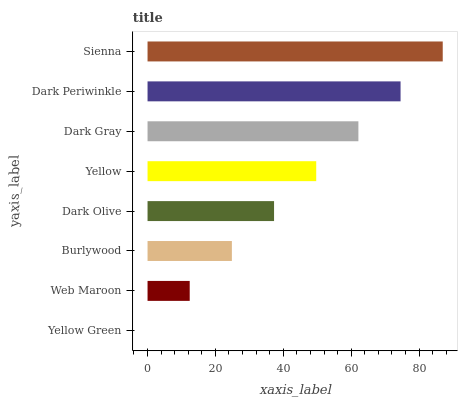Is Yellow Green the minimum?
Answer yes or no. Yes. Is Sienna the maximum?
Answer yes or no. Yes. Is Web Maroon the minimum?
Answer yes or no. No. Is Web Maroon the maximum?
Answer yes or no. No. Is Web Maroon greater than Yellow Green?
Answer yes or no. Yes. Is Yellow Green less than Web Maroon?
Answer yes or no. Yes. Is Yellow Green greater than Web Maroon?
Answer yes or no. No. Is Web Maroon less than Yellow Green?
Answer yes or no. No. Is Yellow the high median?
Answer yes or no. Yes. Is Dark Olive the low median?
Answer yes or no. Yes. Is Dark Periwinkle the high median?
Answer yes or no. No. Is Yellow the low median?
Answer yes or no. No. 